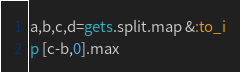<code> <loc_0><loc_0><loc_500><loc_500><_Ruby_>a,b,c,d=gets.split.map &:to_i
p [c-b,0].max</code> 